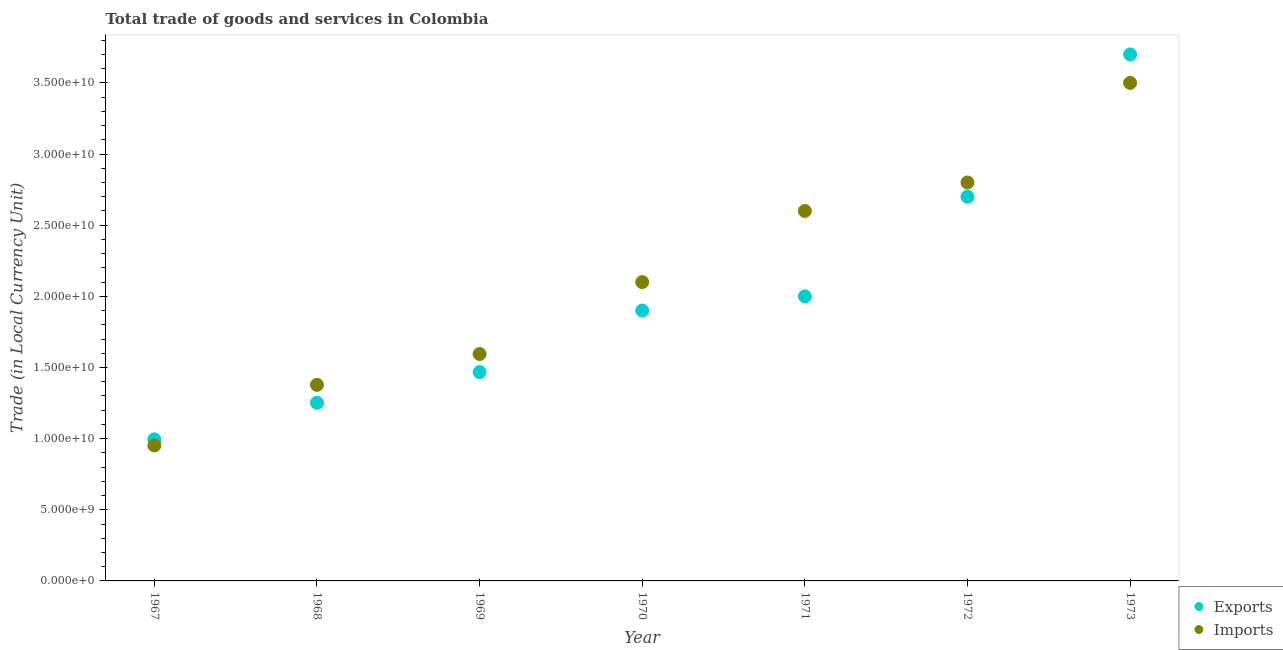How many different coloured dotlines are there?
Your answer should be very brief. 2. What is the export of goods and services in 1971?
Offer a terse response. 2.00e+1. Across all years, what is the maximum export of goods and services?
Your response must be concise. 3.70e+1. Across all years, what is the minimum export of goods and services?
Offer a very short reply. 9.95e+09. In which year was the export of goods and services maximum?
Your answer should be very brief. 1973. In which year was the imports of goods and services minimum?
Offer a very short reply. 1967. What is the total export of goods and services in the graph?
Provide a succinct answer. 1.40e+11. What is the difference between the imports of goods and services in 1971 and that in 1973?
Keep it short and to the point. -9.00e+09. What is the difference between the export of goods and services in 1973 and the imports of goods and services in 1970?
Keep it short and to the point. 1.60e+1. What is the average export of goods and services per year?
Offer a very short reply. 2.00e+1. In the year 1967, what is the difference between the imports of goods and services and export of goods and services?
Your response must be concise. -4.29e+08. In how many years, is the imports of goods and services greater than 18000000000 LCU?
Your answer should be very brief. 4. What is the ratio of the export of goods and services in 1969 to that in 1973?
Give a very brief answer. 0.4. What is the difference between the highest and the second highest imports of goods and services?
Keep it short and to the point. 7.00e+09. What is the difference between the highest and the lowest imports of goods and services?
Your response must be concise. 2.55e+1. Is the sum of the export of goods and services in 1967 and 1969 greater than the maximum imports of goods and services across all years?
Offer a terse response. No. Is the export of goods and services strictly less than the imports of goods and services over the years?
Ensure brevity in your answer.  No. How many dotlines are there?
Your answer should be very brief. 2. What is the difference between two consecutive major ticks on the Y-axis?
Make the answer very short. 5.00e+09. Are the values on the major ticks of Y-axis written in scientific E-notation?
Your answer should be very brief. Yes. What is the title of the graph?
Make the answer very short. Total trade of goods and services in Colombia. Does "UN agencies" appear as one of the legend labels in the graph?
Your answer should be compact. No. What is the label or title of the X-axis?
Keep it short and to the point. Year. What is the label or title of the Y-axis?
Offer a very short reply. Trade (in Local Currency Unit). What is the Trade (in Local Currency Unit) in Exports in 1967?
Your answer should be compact. 9.95e+09. What is the Trade (in Local Currency Unit) of Imports in 1967?
Your answer should be very brief. 9.52e+09. What is the Trade (in Local Currency Unit) of Exports in 1968?
Your answer should be compact. 1.25e+1. What is the Trade (in Local Currency Unit) of Imports in 1968?
Offer a terse response. 1.38e+1. What is the Trade (in Local Currency Unit) in Exports in 1969?
Give a very brief answer. 1.47e+1. What is the Trade (in Local Currency Unit) of Imports in 1969?
Offer a terse response. 1.59e+1. What is the Trade (in Local Currency Unit) in Exports in 1970?
Keep it short and to the point. 1.90e+1. What is the Trade (in Local Currency Unit) in Imports in 1970?
Your answer should be very brief. 2.10e+1. What is the Trade (in Local Currency Unit) in Imports in 1971?
Ensure brevity in your answer.  2.60e+1. What is the Trade (in Local Currency Unit) in Exports in 1972?
Your answer should be compact. 2.70e+1. What is the Trade (in Local Currency Unit) in Imports in 1972?
Give a very brief answer. 2.80e+1. What is the Trade (in Local Currency Unit) of Exports in 1973?
Your response must be concise. 3.70e+1. What is the Trade (in Local Currency Unit) of Imports in 1973?
Offer a very short reply. 3.50e+1. Across all years, what is the maximum Trade (in Local Currency Unit) of Exports?
Offer a terse response. 3.70e+1. Across all years, what is the maximum Trade (in Local Currency Unit) of Imports?
Your answer should be compact. 3.50e+1. Across all years, what is the minimum Trade (in Local Currency Unit) in Exports?
Your answer should be very brief. 9.95e+09. Across all years, what is the minimum Trade (in Local Currency Unit) in Imports?
Ensure brevity in your answer.  9.52e+09. What is the total Trade (in Local Currency Unit) of Exports in the graph?
Give a very brief answer. 1.40e+11. What is the total Trade (in Local Currency Unit) in Imports in the graph?
Make the answer very short. 1.49e+11. What is the difference between the Trade (in Local Currency Unit) in Exports in 1967 and that in 1968?
Your answer should be compact. -2.57e+09. What is the difference between the Trade (in Local Currency Unit) in Imports in 1967 and that in 1968?
Offer a very short reply. -4.26e+09. What is the difference between the Trade (in Local Currency Unit) in Exports in 1967 and that in 1969?
Ensure brevity in your answer.  -4.72e+09. What is the difference between the Trade (in Local Currency Unit) in Imports in 1967 and that in 1969?
Your answer should be very brief. -6.43e+09. What is the difference between the Trade (in Local Currency Unit) of Exports in 1967 and that in 1970?
Ensure brevity in your answer.  -9.05e+09. What is the difference between the Trade (in Local Currency Unit) in Imports in 1967 and that in 1970?
Offer a very short reply. -1.15e+1. What is the difference between the Trade (in Local Currency Unit) in Exports in 1967 and that in 1971?
Provide a short and direct response. -1.00e+1. What is the difference between the Trade (in Local Currency Unit) in Imports in 1967 and that in 1971?
Your answer should be very brief. -1.65e+1. What is the difference between the Trade (in Local Currency Unit) of Exports in 1967 and that in 1972?
Provide a short and direct response. -1.70e+1. What is the difference between the Trade (in Local Currency Unit) of Imports in 1967 and that in 1972?
Ensure brevity in your answer.  -1.85e+1. What is the difference between the Trade (in Local Currency Unit) in Exports in 1967 and that in 1973?
Offer a very short reply. -2.70e+1. What is the difference between the Trade (in Local Currency Unit) of Imports in 1967 and that in 1973?
Ensure brevity in your answer.  -2.55e+1. What is the difference between the Trade (in Local Currency Unit) of Exports in 1968 and that in 1969?
Your answer should be very brief. -2.16e+09. What is the difference between the Trade (in Local Currency Unit) in Imports in 1968 and that in 1969?
Provide a short and direct response. -2.17e+09. What is the difference between the Trade (in Local Currency Unit) of Exports in 1968 and that in 1970?
Offer a very short reply. -6.48e+09. What is the difference between the Trade (in Local Currency Unit) of Imports in 1968 and that in 1970?
Your answer should be very brief. -7.22e+09. What is the difference between the Trade (in Local Currency Unit) of Exports in 1968 and that in 1971?
Provide a short and direct response. -7.48e+09. What is the difference between the Trade (in Local Currency Unit) in Imports in 1968 and that in 1971?
Offer a very short reply. -1.22e+1. What is the difference between the Trade (in Local Currency Unit) of Exports in 1968 and that in 1972?
Keep it short and to the point. -1.45e+1. What is the difference between the Trade (in Local Currency Unit) in Imports in 1968 and that in 1972?
Offer a very short reply. -1.42e+1. What is the difference between the Trade (in Local Currency Unit) in Exports in 1968 and that in 1973?
Give a very brief answer. -2.45e+1. What is the difference between the Trade (in Local Currency Unit) in Imports in 1968 and that in 1973?
Offer a terse response. -2.12e+1. What is the difference between the Trade (in Local Currency Unit) of Exports in 1969 and that in 1970?
Your response must be concise. -4.32e+09. What is the difference between the Trade (in Local Currency Unit) of Imports in 1969 and that in 1970?
Your answer should be compact. -5.05e+09. What is the difference between the Trade (in Local Currency Unit) of Exports in 1969 and that in 1971?
Make the answer very short. -5.32e+09. What is the difference between the Trade (in Local Currency Unit) of Imports in 1969 and that in 1971?
Provide a succinct answer. -1.01e+1. What is the difference between the Trade (in Local Currency Unit) in Exports in 1969 and that in 1972?
Your answer should be very brief. -1.23e+1. What is the difference between the Trade (in Local Currency Unit) of Imports in 1969 and that in 1972?
Provide a succinct answer. -1.21e+1. What is the difference between the Trade (in Local Currency Unit) in Exports in 1969 and that in 1973?
Offer a very short reply. -2.23e+1. What is the difference between the Trade (in Local Currency Unit) in Imports in 1969 and that in 1973?
Your answer should be compact. -1.91e+1. What is the difference between the Trade (in Local Currency Unit) of Exports in 1970 and that in 1971?
Give a very brief answer. -1.00e+09. What is the difference between the Trade (in Local Currency Unit) in Imports in 1970 and that in 1971?
Offer a very short reply. -5.00e+09. What is the difference between the Trade (in Local Currency Unit) of Exports in 1970 and that in 1972?
Ensure brevity in your answer.  -8.00e+09. What is the difference between the Trade (in Local Currency Unit) in Imports in 1970 and that in 1972?
Ensure brevity in your answer.  -7.00e+09. What is the difference between the Trade (in Local Currency Unit) in Exports in 1970 and that in 1973?
Give a very brief answer. -1.80e+1. What is the difference between the Trade (in Local Currency Unit) of Imports in 1970 and that in 1973?
Give a very brief answer. -1.40e+1. What is the difference between the Trade (in Local Currency Unit) of Exports in 1971 and that in 1972?
Give a very brief answer. -7.00e+09. What is the difference between the Trade (in Local Currency Unit) in Imports in 1971 and that in 1972?
Keep it short and to the point. -2.00e+09. What is the difference between the Trade (in Local Currency Unit) in Exports in 1971 and that in 1973?
Make the answer very short. -1.70e+1. What is the difference between the Trade (in Local Currency Unit) of Imports in 1971 and that in 1973?
Provide a succinct answer. -9.00e+09. What is the difference between the Trade (in Local Currency Unit) in Exports in 1972 and that in 1973?
Ensure brevity in your answer.  -1.00e+1. What is the difference between the Trade (in Local Currency Unit) of Imports in 1972 and that in 1973?
Provide a succinct answer. -7.00e+09. What is the difference between the Trade (in Local Currency Unit) in Exports in 1967 and the Trade (in Local Currency Unit) in Imports in 1968?
Your response must be concise. -3.83e+09. What is the difference between the Trade (in Local Currency Unit) in Exports in 1967 and the Trade (in Local Currency Unit) in Imports in 1969?
Give a very brief answer. -6.00e+09. What is the difference between the Trade (in Local Currency Unit) in Exports in 1967 and the Trade (in Local Currency Unit) in Imports in 1970?
Give a very brief answer. -1.10e+1. What is the difference between the Trade (in Local Currency Unit) in Exports in 1967 and the Trade (in Local Currency Unit) in Imports in 1971?
Ensure brevity in your answer.  -1.60e+1. What is the difference between the Trade (in Local Currency Unit) in Exports in 1967 and the Trade (in Local Currency Unit) in Imports in 1972?
Provide a succinct answer. -1.80e+1. What is the difference between the Trade (in Local Currency Unit) in Exports in 1967 and the Trade (in Local Currency Unit) in Imports in 1973?
Your answer should be compact. -2.50e+1. What is the difference between the Trade (in Local Currency Unit) in Exports in 1968 and the Trade (in Local Currency Unit) in Imports in 1969?
Your answer should be compact. -3.43e+09. What is the difference between the Trade (in Local Currency Unit) in Exports in 1968 and the Trade (in Local Currency Unit) in Imports in 1970?
Offer a terse response. -8.48e+09. What is the difference between the Trade (in Local Currency Unit) in Exports in 1968 and the Trade (in Local Currency Unit) in Imports in 1971?
Keep it short and to the point. -1.35e+1. What is the difference between the Trade (in Local Currency Unit) of Exports in 1968 and the Trade (in Local Currency Unit) of Imports in 1972?
Provide a short and direct response. -1.55e+1. What is the difference between the Trade (in Local Currency Unit) in Exports in 1968 and the Trade (in Local Currency Unit) in Imports in 1973?
Give a very brief answer. -2.25e+1. What is the difference between the Trade (in Local Currency Unit) in Exports in 1969 and the Trade (in Local Currency Unit) in Imports in 1970?
Your answer should be very brief. -6.32e+09. What is the difference between the Trade (in Local Currency Unit) in Exports in 1969 and the Trade (in Local Currency Unit) in Imports in 1971?
Provide a succinct answer. -1.13e+1. What is the difference between the Trade (in Local Currency Unit) in Exports in 1969 and the Trade (in Local Currency Unit) in Imports in 1972?
Make the answer very short. -1.33e+1. What is the difference between the Trade (in Local Currency Unit) of Exports in 1969 and the Trade (in Local Currency Unit) of Imports in 1973?
Your answer should be compact. -2.03e+1. What is the difference between the Trade (in Local Currency Unit) of Exports in 1970 and the Trade (in Local Currency Unit) of Imports in 1971?
Keep it short and to the point. -7.00e+09. What is the difference between the Trade (in Local Currency Unit) in Exports in 1970 and the Trade (in Local Currency Unit) in Imports in 1972?
Give a very brief answer. -9.00e+09. What is the difference between the Trade (in Local Currency Unit) of Exports in 1970 and the Trade (in Local Currency Unit) of Imports in 1973?
Your answer should be very brief. -1.60e+1. What is the difference between the Trade (in Local Currency Unit) in Exports in 1971 and the Trade (in Local Currency Unit) in Imports in 1972?
Offer a very short reply. -8.00e+09. What is the difference between the Trade (in Local Currency Unit) in Exports in 1971 and the Trade (in Local Currency Unit) in Imports in 1973?
Your answer should be compact. -1.50e+1. What is the difference between the Trade (in Local Currency Unit) of Exports in 1972 and the Trade (in Local Currency Unit) of Imports in 1973?
Your answer should be very brief. -8.00e+09. What is the average Trade (in Local Currency Unit) of Exports per year?
Your response must be concise. 2.00e+1. What is the average Trade (in Local Currency Unit) in Imports per year?
Your answer should be compact. 2.13e+1. In the year 1967, what is the difference between the Trade (in Local Currency Unit) of Exports and Trade (in Local Currency Unit) of Imports?
Your response must be concise. 4.29e+08. In the year 1968, what is the difference between the Trade (in Local Currency Unit) of Exports and Trade (in Local Currency Unit) of Imports?
Your answer should be compact. -1.26e+09. In the year 1969, what is the difference between the Trade (in Local Currency Unit) of Exports and Trade (in Local Currency Unit) of Imports?
Provide a short and direct response. -1.27e+09. In the year 1970, what is the difference between the Trade (in Local Currency Unit) in Exports and Trade (in Local Currency Unit) in Imports?
Provide a short and direct response. -2.00e+09. In the year 1971, what is the difference between the Trade (in Local Currency Unit) in Exports and Trade (in Local Currency Unit) in Imports?
Your answer should be very brief. -6.00e+09. In the year 1972, what is the difference between the Trade (in Local Currency Unit) of Exports and Trade (in Local Currency Unit) of Imports?
Provide a short and direct response. -1.00e+09. In the year 1973, what is the difference between the Trade (in Local Currency Unit) in Exports and Trade (in Local Currency Unit) in Imports?
Your answer should be compact. 2.00e+09. What is the ratio of the Trade (in Local Currency Unit) in Exports in 1967 to that in 1968?
Your answer should be compact. 0.79. What is the ratio of the Trade (in Local Currency Unit) of Imports in 1967 to that in 1968?
Give a very brief answer. 0.69. What is the ratio of the Trade (in Local Currency Unit) of Exports in 1967 to that in 1969?
Make the answer very short. 0.68. What is the ratio of the Trade (in Local Currency Unit) in Imports in 1967 to that in 1969?
Provide a succinct answer. 0.6. What is the ratio of the Trade (in Local Currency Unit) of Exports in 1967 to that in 1970?
Your answer should be very brief. 0.52. What is the ratio of the Trade (in Local Currency Unit) of Imports in 1967 to that in 1970?
Your answer should be compact. 0.45. What is the ratio of the Trade (in Local Currency Unit) of Exports in 1967 to that in 1971?
Provide a short and direct response. 0.5. What is the ratio of the Trade (in Local Currency Unit) of Imports in 1967 to that in 1971?
Provide a short and direct response. 0.37. What is the ratio of the Trade (in Local Currency Unit) in Exports in 1967 to that in 1972?
Your answer should be very brief. 0.37. What is the ratio of the Trade (in Local Currency Unit) in Imports in 1967 to that in 1972?
Your answer should be compact. 0.34. What is the ratio of the Trade (in Local Currency Unit) of Exports in 1967 to that in 1973?
Keep it short and to the point. 0.27. What is the ratio of the Trade (in Local Currency Unit) of Imports in 1967 to that in 1973?
Provide a short and direct response. 0.27. What is the ratio of the Trade (in Local Currency Unit) of Exports in 1968 to that in 1969?
Give a very brief answer. 0.85. What is the ratio of the Trade (in Local Currency Unit) in Imports in 1968 to that in 1969?
Give a very brief answer. 0.86. What is the ratio of the Trade (in Local Currency Unit) in Exports in 1968 to that in 1970?
Provide a short and direct response. 0.66. What is the ratio of the Trade (in Local Currency Unit) in Imports in 1968 to that in 1970?
Your answer should be compact. 0.66. What is the ratio of the Trade (in Local Currency Unit) of Exports in 1968 to that in 1971?
Your answer should be very brief. 0.63. What is the ratio of the Trade (in Local Currency Unit) in Imports in 1968 to that in 1971?
Your answer should be very brief. 0.53. What is the ratio of the Trade (in Local Currency Unit) of Exports in 1968 to that in 1972?
Make the answer very short. 0.46. What is the ratio of the Trade (in Local Currency Unit) in Imports in 1968 to that in 1972?
Your answer should be very brief. 0.49. What is the ratio of the Trade (in Local Currency Unit) of Exports in 1968 to that in 1973?
Keep it short and to the point. 0.34. What is the ratio of the Trade (in Local Currency Unit) in Imports in 1968 to that in 1973?
Your answer should be very brief. 0.39. What is the ratio of the Trade (in Local Currency Unit) of Exports in 1969 to that in 1970?
Your answer should be compact. 0.77. What is the ratio of the Trade (in Local Currency Unit) of Imports in 1969 to that in 1970?
Your answer should be very brief. 0.76. What is the ratio of the Trade (in Local Currency Unit) of Exports in 1969 to that in 1971?
Provide a succinct answer. 0.73. What is the ratio of the Trade (in Local Currency Unit) in Imports in 1969 to that in 1971?
Keep it short and to the point. 0.61. What is the ratio of the Trade (in Local Currency Unit) of Exports in 1969 to that in 1972?
Offer a very short reply. 0.54. What is the ratio of the Trade (in Local Currency Unit) of Imports in 1969 to that in 1972?
Your answer should be compact. 0.57. What is the ratio of the Trade (in Local Currency Unit) in Exports in 1969 to that in 1973?
Give a very brief answer. 0.4. What is the ratio of the Trade (in Local Currency Unit) in Imports in 1969 to that in 1973?
Provide a succinct answer. 0.46. What is the ratio of the Trade (in Local Currency Unit) of Exports in 1970 to that in 1971?
Offer a very short reply. 0.95. What is the ratio of the Trade (in Local Currency Unit) in Imports in 1970 to that in 1971?
Offer a very short reply. 0.81. What is the ratio of the Trade (in Local Currency Unit) in Exports in 1970 to that in 1972?
Offer a very short reply. 0.7. What is the ratio of the Trade (in Local Currency Unit) of Exports in 1970 to that in 1973?
Offer a very short reply. 0.51. What is the ratio of the Trade (in Local Currency Unit) in Imports in 1970 to that in 1973?
Your response must be concise. 0.6. What is the ratio of the Trade (in Local Currency Unit) in Exports in 1971 to that in 1972?
Your answer should be compact. 0.74. What is the ratio of the Trade (in Local Currency Unit) in Exports in 1971 to that in 1973?
Offer a very short reply. 0.54. What is the ratio of the Trade (in Local Currency Unit) of Imports in 1971 to that in 1973?
Provide a succinct answer. 0.74. What is the ratio of the Trade (in Local Currency Unit) of Exports in 1972 to that in 1973?
Keep it short and to the point. 0.73. What is the ratio of the Trade (in Local Currency Unit) in Imports in 1972 to that in 1973?
Ensure brevity in your answer.  0.8. What is the difference between the highest and the second highest Trade (in Local Currency Unit) of Exports?
Provide a succinct answer. 1.00e+1. What is the difference between the highest and the second highest Trade (in Local Currency Unit) in Imports?
Offer a terse response. 7.00e+09. What is the difference between the highest and the lowest Trade (in Local Currency Unit) in Exports?
Keep it short and to the point. 2.70e+1. What is the difference between the highest and the lowest Trade (in Local Currency Unit) of Imports?
Your answer should be very brief. 2.55e+1. 